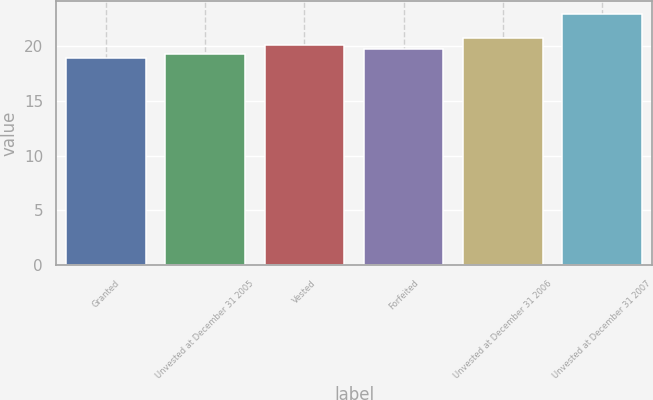Convert chart. <chart><loc_0><loc_0><loc_500><loc_500><bar_chart><fcel>Granted<fcel>Unvested at December 31 2005<fcel>Vested<fcel>Forfeited<fcel>Unvested at December 31 2006<fcel>Unvested at December 31 2007<nl><fcel>18.89<fcel>19.29<fcel>20.09<fcel>19.69<fcel>20.68<fcel>22.92<nl></chart> 